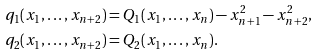Convert formula to latex. <formula><loc_0><loc_0><loc_500><loc_500>q _ { 1 } ( x _ { 1 } , \dots , x _ { n + 2 } ) & = Q _ { 1 } ( x _ { 1 } , \dots , x _ { n } ) - x _ { n + 1 } ^ { 2 } - x _ { n + 2 } ^ { 2 } , \\ q _ { 2 } ( x _ { 1 } , \dots , x _ { n + 2 } ) & = Q _ { 2 } ( x _ { 1 } , \dots , x _ { n } ) .</formula> 